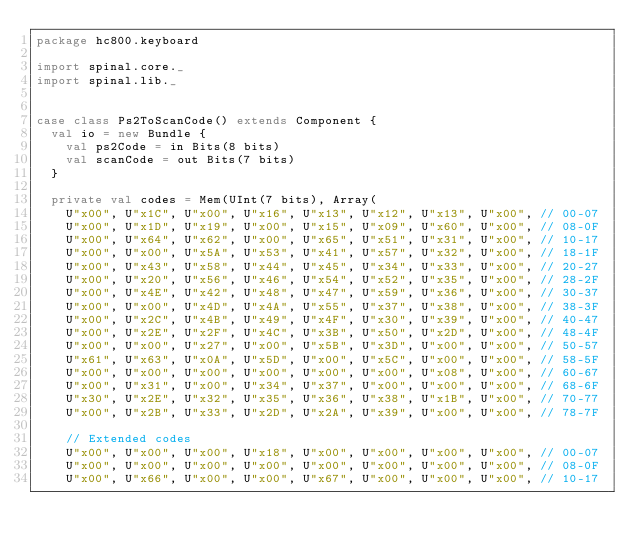Convert code to text. <code><loc_0><loc_0><loc_500><loc_500><_Scala_>package hc800.keyboard

import spinal.core._
import spinal.lib._


case class Ps2ToScanCode() extends Component {
	val io = new Bundle {
		val ps2Code = in Bits(8 bits)
		val scanCode = out Bits(7 bits)
	}

	private val codes = Mem(UInt(7 bits), Array(
		U"x00", U"x1C", U"x00", U"x16", U"x13", U"x12", U"x13", U"x00",	// 00-07
		U"x00", U"x1D", U"x19", U"x00", U"x15", U"x09", U"x60", U"x00",	// 08-0F
		U"x00", U"x64", U"x62", U"x00", U"x65", U"x51", U"x31", U"x00",	// 10-17
		U"x00", U"x00", U"x5A", U"x53", U"x41", U"x57", U"x32", U"x00",	// 18-1F
		U"x00", U"x43", U"x58", U"x44", U"x45", U"x34", U"x33", U"x00",	// 20-27
		U"x00", U"x20", U"x56", U"x46", U"x54", U"x52", U"x35", U"x00",	// 28-2F
		U"x00", U"x4E", U"x42", U"x48", U"x47", U"x59", U"x36", U"x00",	// 30-37
		U"x00", U"x00", U"x4D", U"x4A", U"x55", U"x37", U"x38", U"x00", // 38-3F
		U"x00", U"x2C", U"x4B", U"x49", U"x4F", U"x30", U"x39", U"x00", // 40-47
		U"x00", U"x2E", U"x2F", U"x4C", U"x3B", U"x50", U"x2D", U"x00", // 48-4F
		U"x00", U"x00", U"x27", U"x00", U"x5B", U"x3D", U"x00", U"x00", // 50-57
		U"x61", U"x63", U"x0A", U"x5D", U"x00", U"x5C", U"x00", U"x00", // 58-5F
		U"x00", U"x00", U"x00", U"x00", U"x00", U"x00", U"x08", U"x00", // 60-67
		U"x00", U"x31", U"x00", U"x34", U"x37", U"x00", U"x00", U"x00", // 68-6F
		U"x30", U"x2E", U"x32", U"x35", U"x36", U"x38", U"x1B", U"x00", // 70-77
		U"x00", U"x2B", U"x33", U"x2D", U"x2A", U"x39", U"x00", U"x00", // 78-7F

		// Extended codes
		U"x00", U"x00", U"x00", U"x18", U"x00", U"x00", U"x00", U"x00", // 00-07
		U"x00", U"x00", U"x00", U"x00", U"x00", U"x00", U"x00", U"x00", // 08-0F
		U"x00", U"x66", U"x00", U"x00", U"x67", U"x00", U"x00", U"x00", // 10-17</code> 